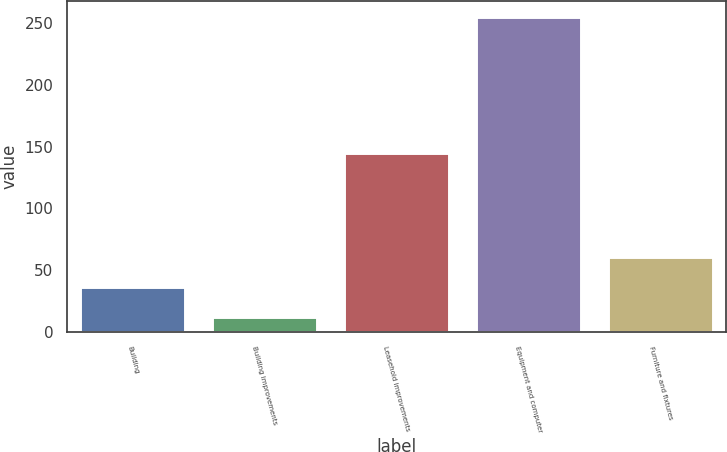Convert chart to OTSL. <chart><loc_0><loc_0><loc_500><loc_500><bar_chart><fcel>Building<fcel>Building improvements<fcel>Leasehold improvements<fcel>Equipment and computer<fcel>Furniture and fixtures<nl><fcel>36.3<fcel>12<fcel>145<fcel>255<fcel>60.6<nl></chart> 